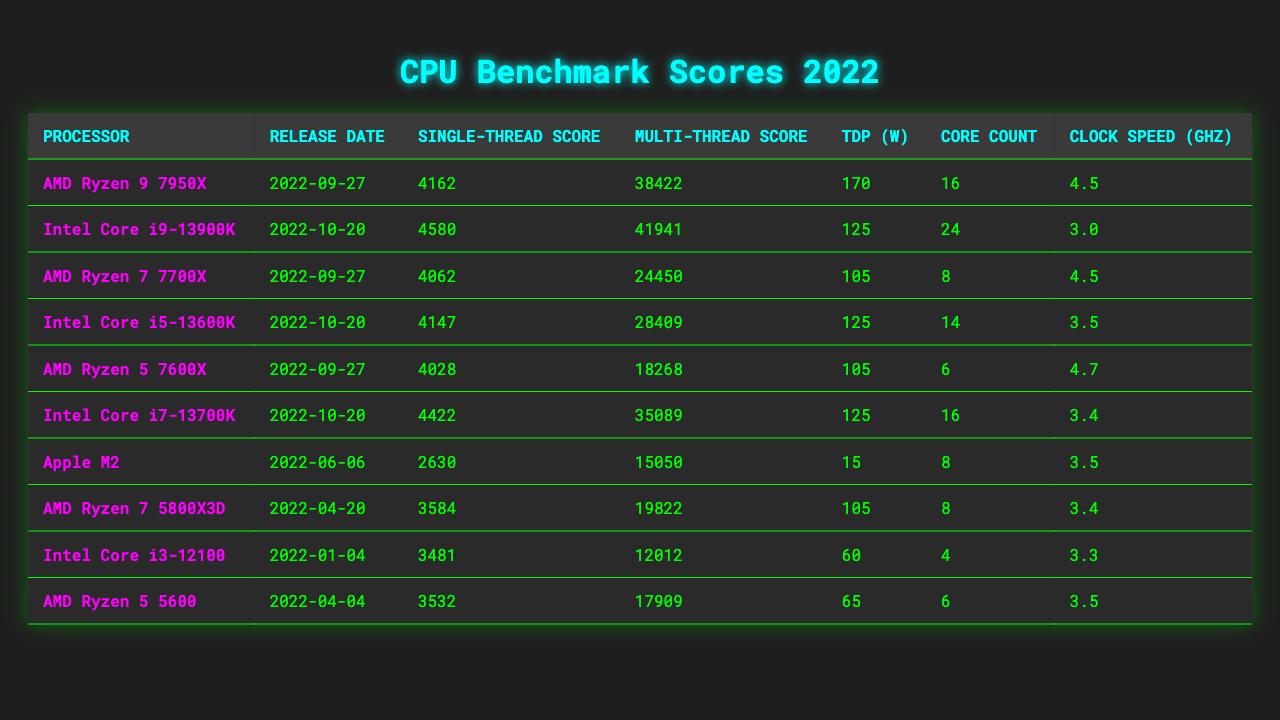What is the single-thread score of the AMD Ryzen 9 7950X? The single-thread score for the AMD Ryzen 9 7950X can be found directly in the table under the "Single-Thread Score" column next to its name. It is 4162.
Answer: 4162 Which processor has the highest multi-thread score? To find this, we look for the processor with the maximum value in the "Multi-Thread Score" column. The Intel Core i9-13900K has the highest score of 41941.
Answer: Intel Core i9-13900K What is the average clock speed of all the listed processors? First, we add all the clock speeds: 4.5 + 3.0 + 4.5 + 3.5 + 4.7 + 3.4 + 3.5 + 3.4 + 3.3 + 3.5 = 36.0 GHz. There are 10 processors, so we divide 36.0 by 10, giving us an average clock speed of 3.6 GHz.
Answer: 3.6 GHz Is the Intel Core i5-13600K released before the AMD Ryzen 7 7700X? By checking the "Release Date" column, we see that the Intel Core i5-13600K was released on 2022-10-20 and the AMD Ryzen 7 7700X on 2022-09-27. Since 2022-10-20 is after 2022-09-27, the statement is false.
Answer: No How does the TDP of the AMD Ryzen 9 7950X compare to the Intel Core i9-13900K? The TDP of the AMD Ryzen 9 7950X is 170 W, while the Intel Core i9-13900K has a TDP of 125 W. This indicates that the Ryzen 9 7950X has a higher thermal design power, which can suggest it consumes more power and may generate more heat.
Answer: Ryzen 9 7950X has higher TDP Which processor has more cores, and by how many compared to the lowest-core processor? The processor with the highest core count is the Intel Core i9-13900K with 24 cores. The processor with the lowest core count is the Intel Core i3-12100 with 4 cores. The difference is 24 - 4 = 20 cores.
Answer: 20 cores Is the single-thread score of the Apple M2 greater than the single-thread score of the AMD Ryzen 5 7600X? The single-thread score of Apple M2 is 2630, and for the AMD Ryzen 5 7600X, it is 4028. Since 2630 is less than 4028, the statement is false.
Answer: No What is the total multi-thread score of all AMD processors listed in the table? We find the multi-thread scores for AMD processors: 38422 (Ryzen 9 7950X) + 24450 (Ryzen 7 7700X) + 18268 (Ryzen 5 7600X) + 19822 (Ryzen 7 5800X3D) + 17909 (Ryzen 5 5600). Adding these gives us a total of 38422 + 24450 + 18268 + 19822 + 17909 = 118071.
Answer: 118071 Which processor has the lowest TDP and what is its value? The lowest TDP value can be identified in the "TDP (W)" column. The Apple M2 has the lowest TDP at 15 W.
Answer: 15 W How many processors have a single-thread score above 4000? We examine each single-thread score: only the AMD Ryzen 9 7950X, Intel Core i9-13900K, Intel Core i5-13600K, AMD Ryzen 7 7700X, and AMD Ryzen 5 7600X have scores exceeding 4000. This counts to 5 processors.
Answer: 5 processors 